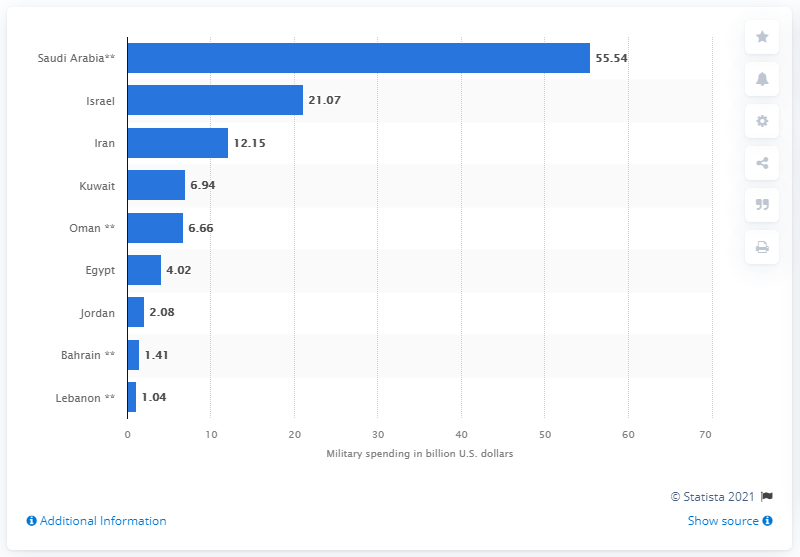Indicate a few pertinent items in this graphic. According to data, Saudi Arabia's military spending in the MENA region in 2020 was approximately 55.54 billion dollars. 